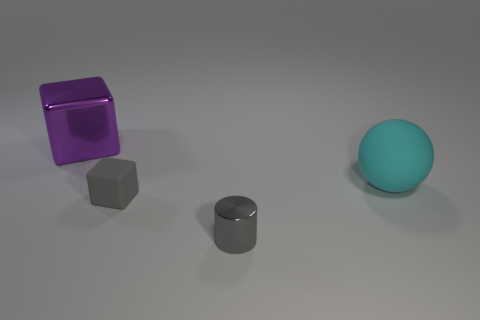Add 1 tiny gray metal cylinders. How many objects exist? 5 Subtract all balls. How many objects are left? 3 Subtract all big purple rubber blocks. Subtract all balls. How many objects are left? 3 Add 2 small gray matte objects. How many small gray matte objects are left? 3 Add 4 cyan matte objects. How many cyan matte objects exist? 5 Subtract 0 blue balls. How many objects are left? 4 